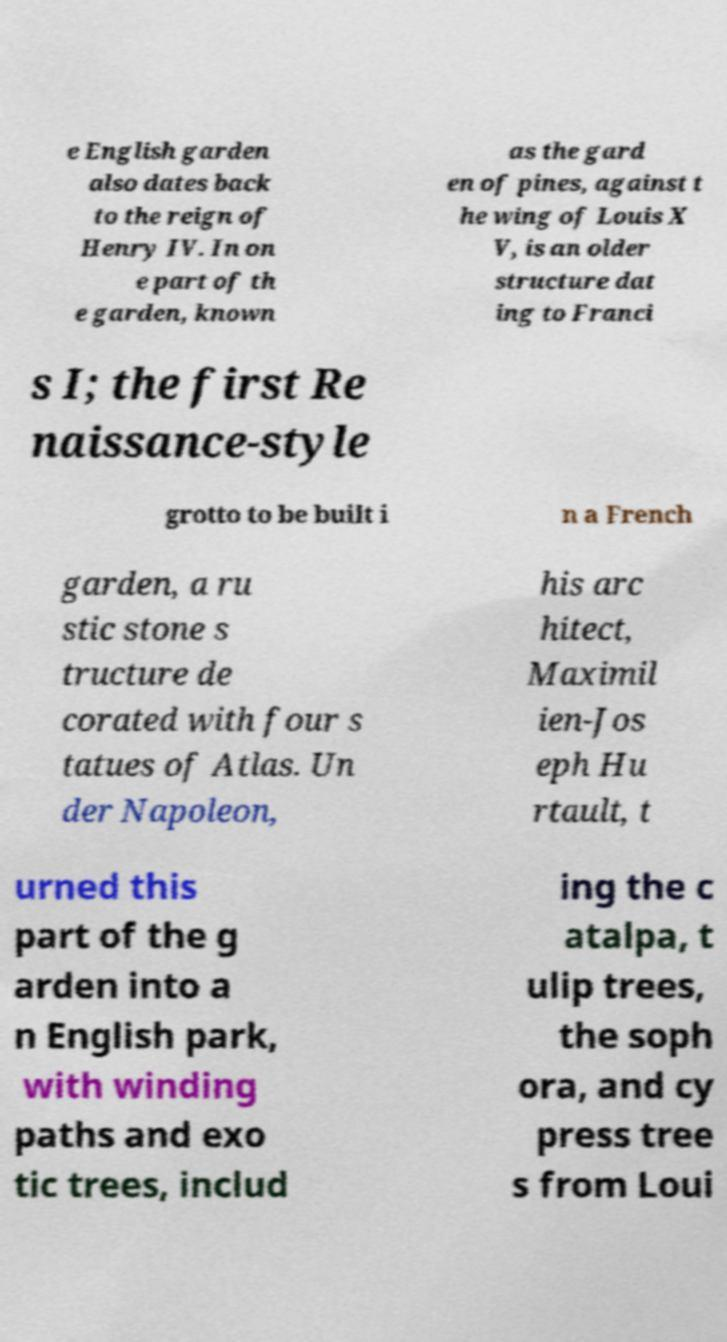What messages or text are displayed in this image? I need them in a readable, typed format. e English garden also dates back to the reign of Henry IV. In on e part of th e garden, known as the gard en of pines, against t he wing of Louis X V, is an older structure dat ing to Franci s I; the first Re naissance-style grotto to be built i n a French garden, a ru stic stone s tructure de corated with four s tatues of Atlas. Un der Napoleon, his arc hitect, Maximil ien-Jos eph Hu rtault, t urned this part of the g arden into a n English park, with winding paths and exo tic trees, includ ing the c atalpa, t ulip trees, the soph ora, and cy press tree s from Loui 